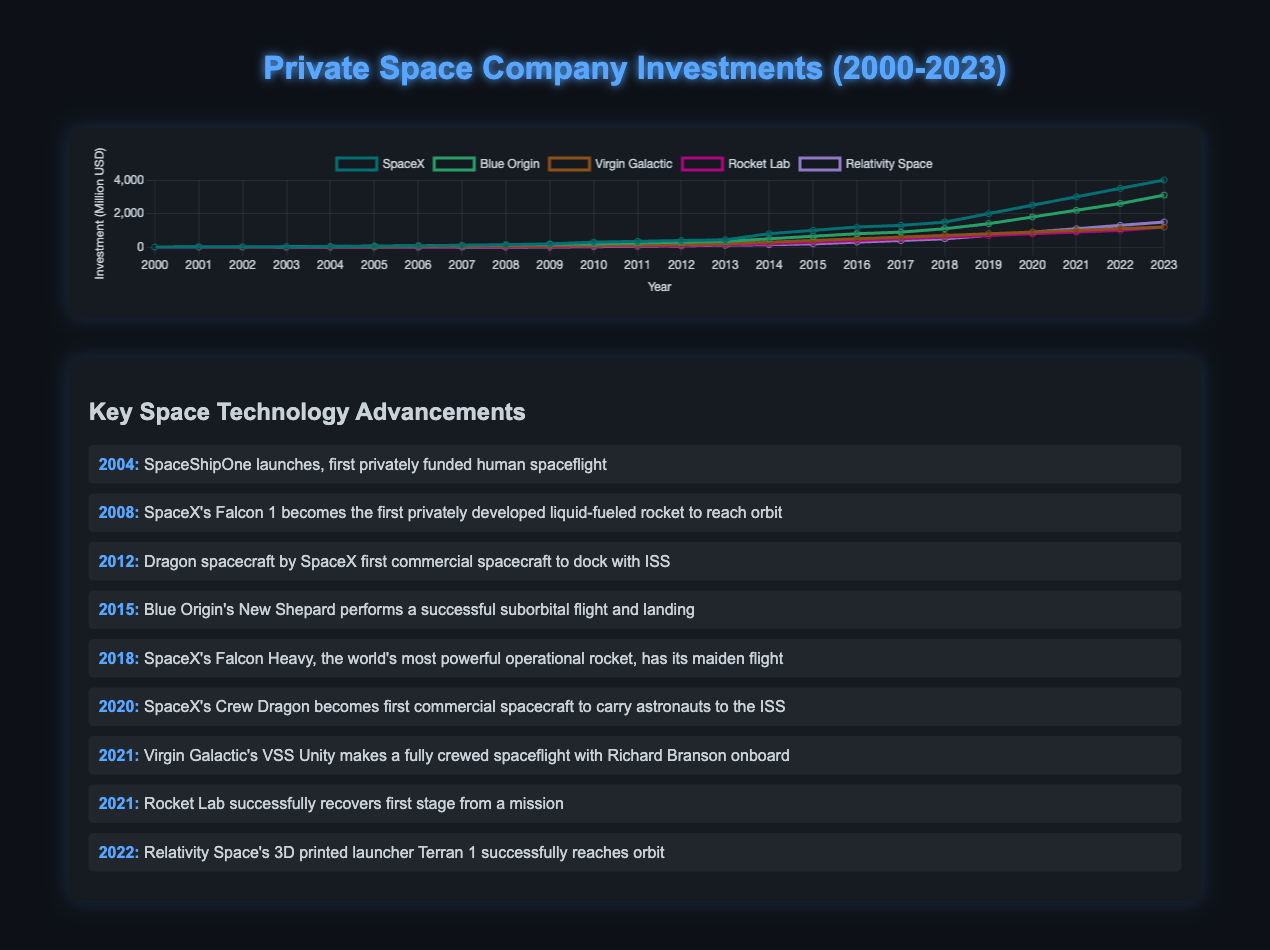Which company had the highest investment in 2023? To find the answer, look at the end of the investment lines in 2023 and identify the company with the highest point.
Answer: SpaceX What was the difference in investment between SpaceX and Rocket Lab in 2020? Locate the investment values for SpaceX and Rocket Lab in 2020, then subtract Rocket Lab's investment from SpaceX's investment. SpaceX's 2020 investment is 2500 million USD, and Rocket Lab's is 800 million USD. The difference is 2500 - 800.
Answer: 1700 million USD Which company showed the first significant increase in investment, and in which year did this occur? Look for the earliest year where there is a noticeable jump in the investment line for any company. SpaceX shows the first significant increase in 2004.
Answer: SpaceX, 2004 By how much did Virgin Galactic’s investment grow from 2005 to 2021? Identify Virgin Galactic’s investment values in 2005 and 2021, then calculate the difference between the two values. Virgin Galactic’s investment grew from 30 million USD in 2005 to 1100 million USD in 2021. The growth is 1100 - 30 million USD.
Answer: 1070 million USD Which company had the least overall investment growth from 2000 to 2023? Compare the starting (2000) and ending (2023) investment values for each company, then find the smallest increase. Virgin Galactic grew from 5 to 1200 million USD, which is less compared to others.
Answer: Virgin Galactic In which year did SpaceX's investment surpass 1000 million USD? Find the year in which SpaceX's investment line first crosses the 1000 million USD mark.
Answer: 2015 Between 2018 and 2021, which company had the highest average yearly investment? Calculate the average yearly investment for each company for the years 2018, 2019, 2020, and 2021. For SpaceX, it is (1500 + 2000 + 2500 + 3000)/4 = 2250. Compare the averages for all companies.
Answer: SpaceX How many years did it take Relativity Space to reach its first 1000 million USD investment? Determine the first year Relativity Space is listed (2010) and the year it first reaches 1000 million USD (2022), then count the number of years between them.
Answer: 12 years What notable technology advancement happened the same year Rocket Lab crossed 1000 million USD in investment? Identify the year when Rocket Lab's line crosses 1000 million USD (2023) and then refer to the technology advancements list for that year.
Answer: Relativity Space's Terran 1 reaching orbit 